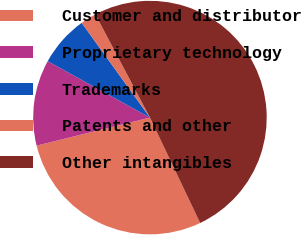Convert chart to OTSL. <chart><loc_0><loc_0><loc_500><loc_500><pie_chart><fcel>Customer and distributor<fcel>Proprietary technology<fcel>Trademarks<fcel>Patents and other<fcel>Other intangibles<nl><fcel>28.21%<fcel>11.89%<fcel>7.04%<fcel>2.19%<fcel>50.67%<nl></chart> 